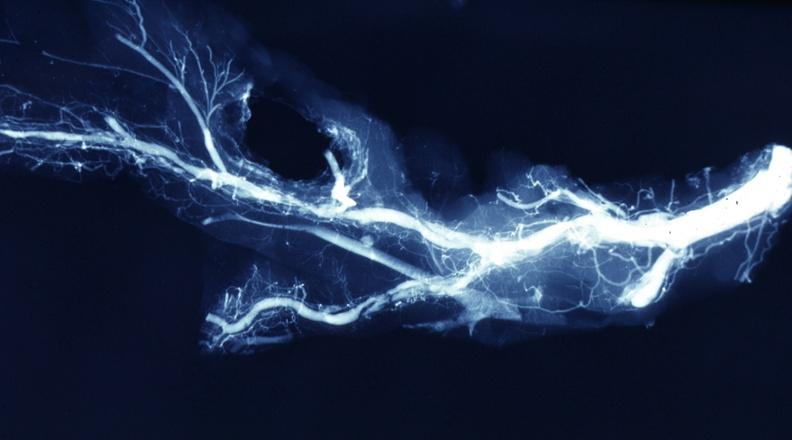what is x-ray postmortdissected?
Answer the question using a single word or phrase. Ray postmortdissected artery lesions in small branches 